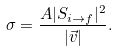Convert formula to latex. <formula><loc_0><loc_0><loc_500><loc_500>\sigma = \frac { A | S _ { i \rightarrow f } | ^ { 2 } } { | \vec { v } | } .</formula> 